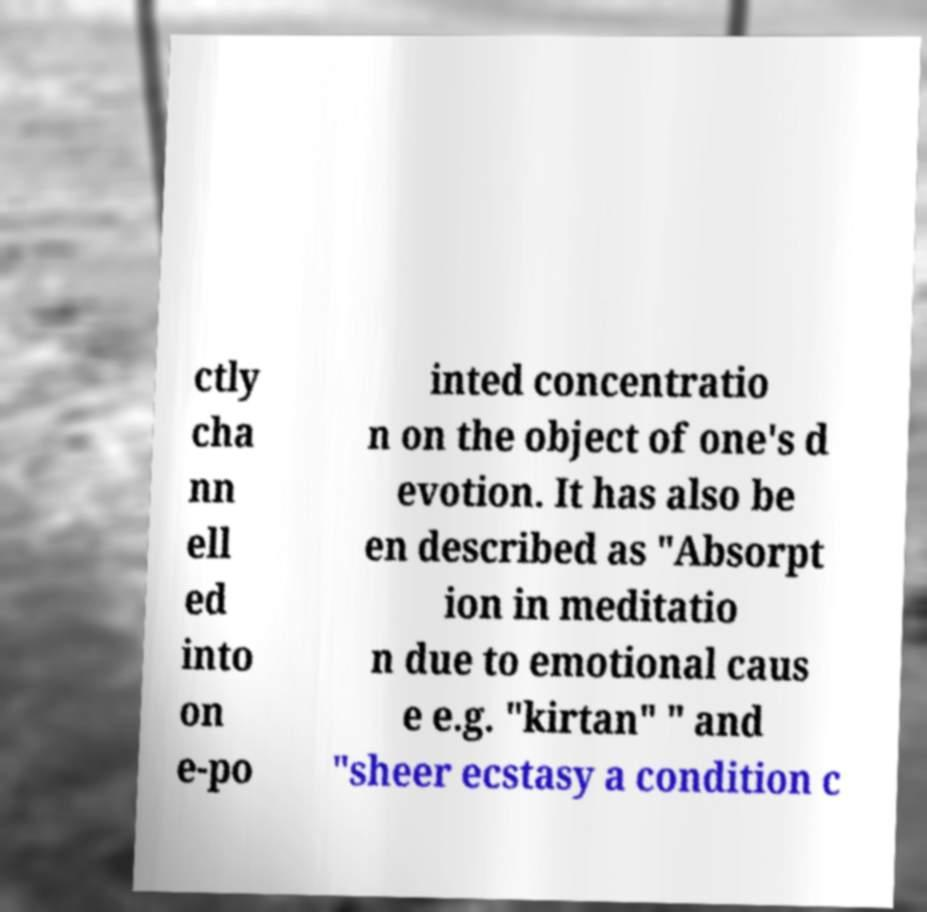Can you accurately transcribe the text from the provided image for me? ctly cha nn ell ed into on e-po inted concentratio n on the object of one's d evotion. It has also be en described as "Absorpt ion in meditatio n due to emotional caus e e.g. "kirtan" " and "sheer ecstasy a condition c 